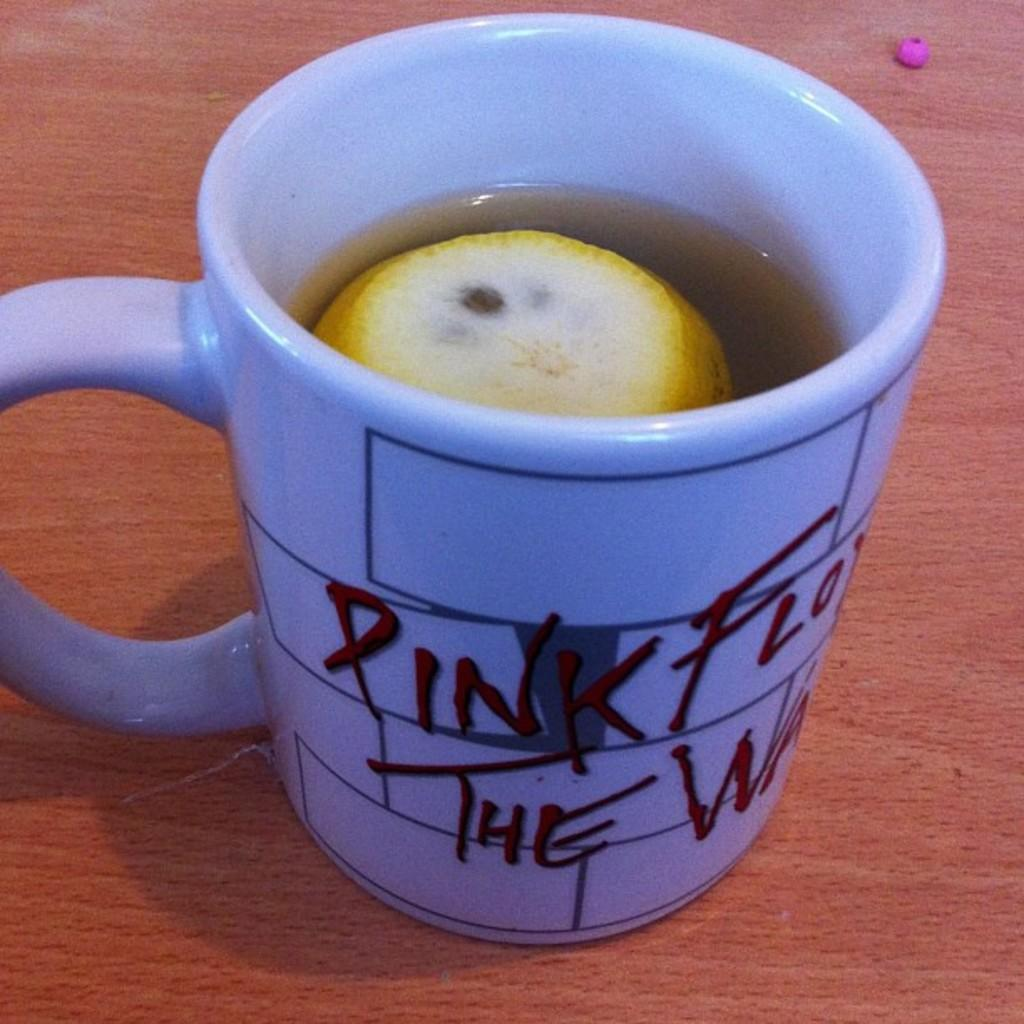<image>
Create a compact narrative representing the image presented. a cup that has the word Pink Floyd on it 